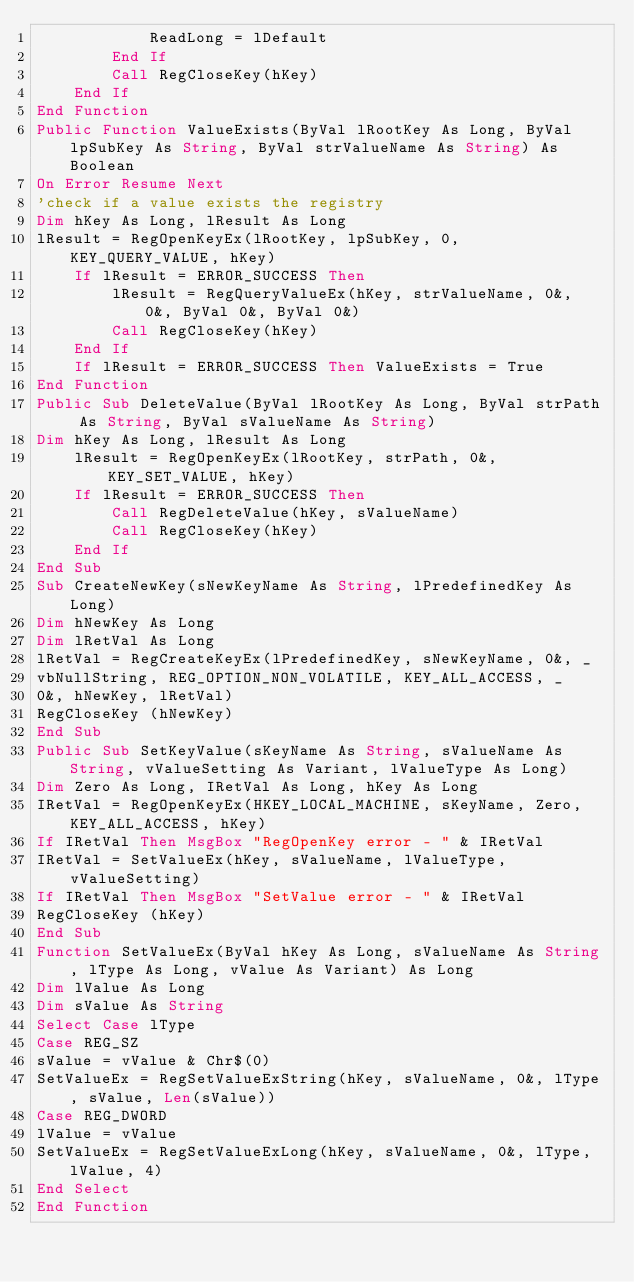<code> <loc_0><loc_0><loc_500><loc_500><_VisualBasic_>            ReadLong = lDefault
        End If
        Call RegCloseKey(hKey)
    End If
End Function
Public Function ValueExists(ByVal lRootKey As Long, ByVal lpSubKey As String, ByVal strValueName As String) As Boolean
On Error Resume Next
'check if a value exists the registry
Dim hKey As Long, lResult As Long
lResult = RegOpenKeyEx(lRootKey, lpSubKey, 0, KEY_QUERY_VALUE, hKey)
    If lResult = ERROR_SUCCESS Then
        lResult = RegQueryValueEx(hKey, strValueName, 0&, 0&, ByVal 0&, ByVal 0&)
        Call RegCloseKey(hKey)
    End If
    If lResult = ERROR_SUCCESS Then ValueExists = True
End Function
Public Sub DeleteValue(ByVal lRootKey As Long, ByVal strPath As String, ByVal sValueName As String)
Dim hKey As Long, lResult As Long
    lResult = RegOpenKeyEx(lRootKey, strPath, 0&, KEY_SET_VALUE, hKey)
    If lResult = ERROR_SUCCESS Then
        Call RegDeleteValue(hKey, sValueName)
        Call RegCloseKey(hKey)
    End If
End Sub
Sub CreateNewKey(sNewKeyName As String, lPredefinedKey As Long)
Dim hNewKey As Long
Dim lRetVal As Long
lRetVal = RegCreateKeyEx(lPredefinedKey, sNewKeyName, 0&, _
vbNullString, REG_OPTION_NON_VOLATILE, KEY_ALL_ACCESS, _
0&, hNewKey, lRetVal)
RegCloseKey (hNewKey)
End Sub
Public Sub SetKeyValue(sKeyName As String, sValueName As String, vValueSetting As Variant, lValueType As Long)
Dim Zero As Long, IRetVal As Long, hKey As Long
IRetVal = RegOpenKeyEx(HKEY_LOCAL_MACHINE, sKeyName, Zero, KEY_ALL_ACCESS, hKey)
If IRetVal Then MsgBox "RegOpenKey error - " & IRetVal
IRetVal = SetValueEx(hKey, sValueName, lValueType, vValueSetting)
If IRetVal Then MsgBox "SetValue error - " & IRetVal
RegCloseKey (hKey)
End Sub
Function SetValueEx(ByVal hKey As Long, sValueName As String, lType As Long, vValue As Variant) As Long
Dim lValue As Long
Dim sValue As String
Select Case lType
Case REG_SZ
sValue = vValue & Chr$(0)
SetValueEx = RegSetValueExString(hKey, sValueName, 0&, lType, sValue, Len(sValue))
Case REG_DWORD
lValue = vValue
SetValueEx = RegSetValueExLong(hKey, sValueName, 0&, lType, lValue, 4)
End Select
End Function
</code> 